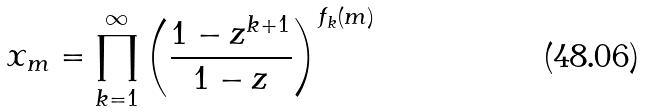Convert formula to latex. <formula><loc_0><loc_0><loc_500><loc_500>x _ { m } = \prod _ { k = 1 } ^ { \infty } \left ( \frac { 1 - z ^ { k + 1 } } { 1 - z } \right ) ^ { f _ { k } ( m ) }</formula> 